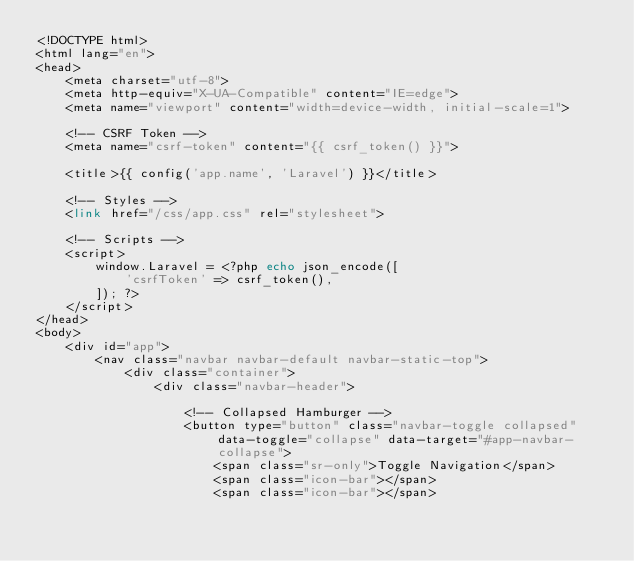<code> <loc_0><loc_0><loc_500><loc_500><_PHP_><!DOCTYPE html>
<html lang="en">
<head>
    <meta charset="utf-8">
    <meta http-equiv="X-UA-Compatible" content="IE=edge">
    <meta name="viewport" content="width=device-width, initial-scale=1">

    <!-- CSRF Token -->
    <meta name="csrf-token" content="{{ csrf_token() }}">

    <title>{{ config('app.name', 'Laravel') }}</title>

    <!-- Styles -->
    <link href="/css/app.css" rel="stylesheet">

    <!-- Scripts -->
    <script>
        window.Laravel = <?php echo json_encode([
            'csrfToken' => csrf_token(),
        ]); ?>
    </script>
</head>
<body>
    <div id="app">
        <nav class="navbar navbar-default navbar-static-top">
            <div class="container">
                <div class="navbar-header">

                    <!-- Collapsed Hamburger -->
                    <button type="button" class="navbar-toggle collapsed" data-toggle="collapse" data-target="#app-navbar-collapse">
                        <span class="sr-only">Toggle Navigation</span>
                        <span class="icon-bar"></span>
                        <span class="icon-bar"></span></code> 